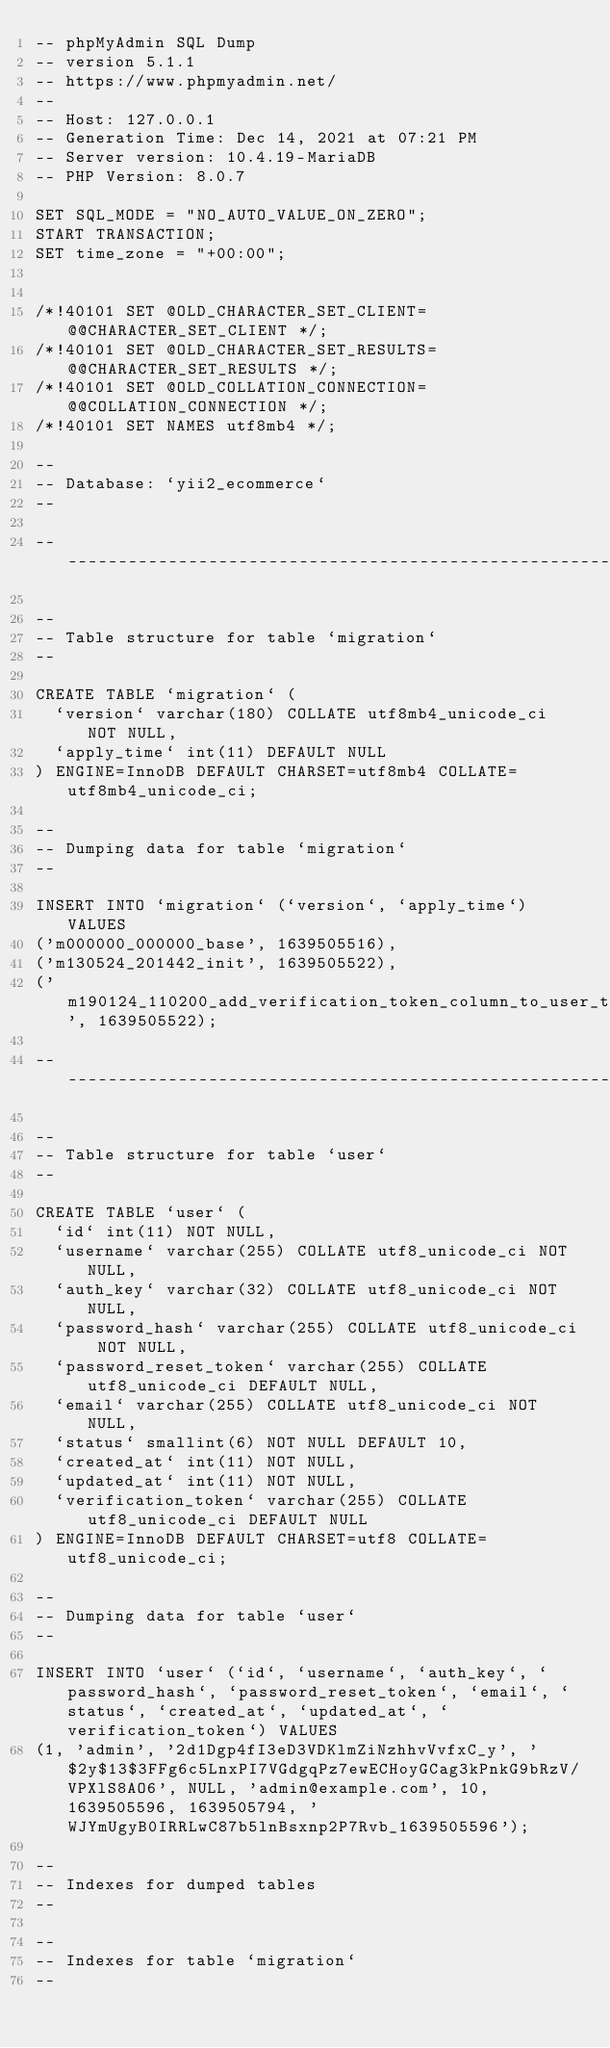<code> <loc_0><loc_0><loc_500><loc_500><_SQL_>-- phpMyAdmin SQL Dump
-- version 5.1.1
-- https://www.phpmyadmin.net/
--
-- Host: 127.0.0.1
-- Generation Time: Dec 14, 2021 at 07:21 PM
-- Server version: 10.4.19-MariaDB
-- PHP Version: 8.0.7

SET SQL_MODE = "NO_AUTO_VALUE_ON_ZERO";
START TRANSACTION;
SET time_zone = "+00:00";


/*!40101 SET @OLD_CHARACTER_SET_CLIENT=@@CHARACTER_SET_CLIENT */;
/*!40101 SET @OLD_CHARACTER_SET_RESULTS=@@CHARACTER_SET_RESULTS */;
/*!40101 SET @OLD_COLLATION_CONNECTION=@@COLLATION_CONNECTION */;
/*!40101 SET NAMES utf8mb4 */;

--
-- Database: `yii2_ecommerce`
--

-- --------------------------------------------------------

--
-- Table structure for table `migration`
--

CREATE TABLE `migration` (
  `version` varchar(180) COLLATE utf8mb4_unicode_ci NOT NULL,
  `apply_time` int(11) DEFAULT NULL
) ENGINE=InnoDB DEFAULT CHARSET=utf8mb4 COLLATE=utf8mb4_unicode_ci;

--
-- Dumping data for table `migration`
--

INSERT INTO `migration` (`version`, `apply_time`) VALUES
('m000000_000000_base', 1639505516),
('m130524_201442_init', 1639505522),
('m190124_110200_add_verification_token_column_to_user_table', 1639505522);

-- --------------------------------------------------------

--
-- Table structure for table `user`
--

CREATE TABLE `user` (
  `id` int(11) NOT NULL,
  `username` varchar(255) COLLATE utf8_unicode_ci NOT NULL,
  `auth_key` varchar(32) COLLATE utf8_unicode_ci NOT NULL,
  `password_hash` varchar(255) COLLATE utf8_unicode_ci NOT NULL,
  `password_reset_token` varchar(255) COLLATE utf8_unicode_ci DEFAULT NULL,
  `email` varchar(255) COLLATE utf8_unicode_ci NOT NULL,
  `status` smallint(6) NOT NULL DEFAULT 10,
  `created_at` int(11) NOT NULL,
  `updated_at` int(11) NOT NULL,
  `verification_token` varchar(255) COLLATE utf8_unicode_ci DEFAULT NULL
) ENGINE=InnoDB DEFAULT CHARSET=utf8 COLLATE=utf8_unicode_ci;

--
-- Dumping data for table `user`
--

INSERT INTO `user` (`id`, `username`, `auth_key`, `password_hash`, `password_reset_token`, `email`, `status`, `created_at`, `updated_at`, `verification_token`) VALUES
(1, 'admin', '2d1Dgp4fI3eD3VDKlmZiNzhhvVvfxC_y', '$2y$13$3FFg6c5LnxPI7VGdgqPz7ewECHoyGCag3kPnkG9bRzV/VPXlS8AO6', NULL, 'admin@example.com', 10, 1639505596, 1639505794, 'WJYmUgyB0IRRLwC87b5lnBsxnp2P7Rvb_1639505596');

--
-- Indexes for dumped tables
--

--
-- Indexes for table `migration`
--</code> 